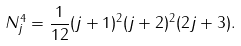<formula> <loc_0><loc_0><loc_500><loc_500>N ^ { 4 } _ { j } = \frac { 1 } { 1 2 } ( j + 1 ) ^ { 2 } ( j + 2 ) ^ { 2 } ( 2 j + 3 ) .</formula> 